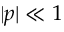<formula> <loc_0><loc_0><loc_500><loc_500>| p | \ll 1</formula> 